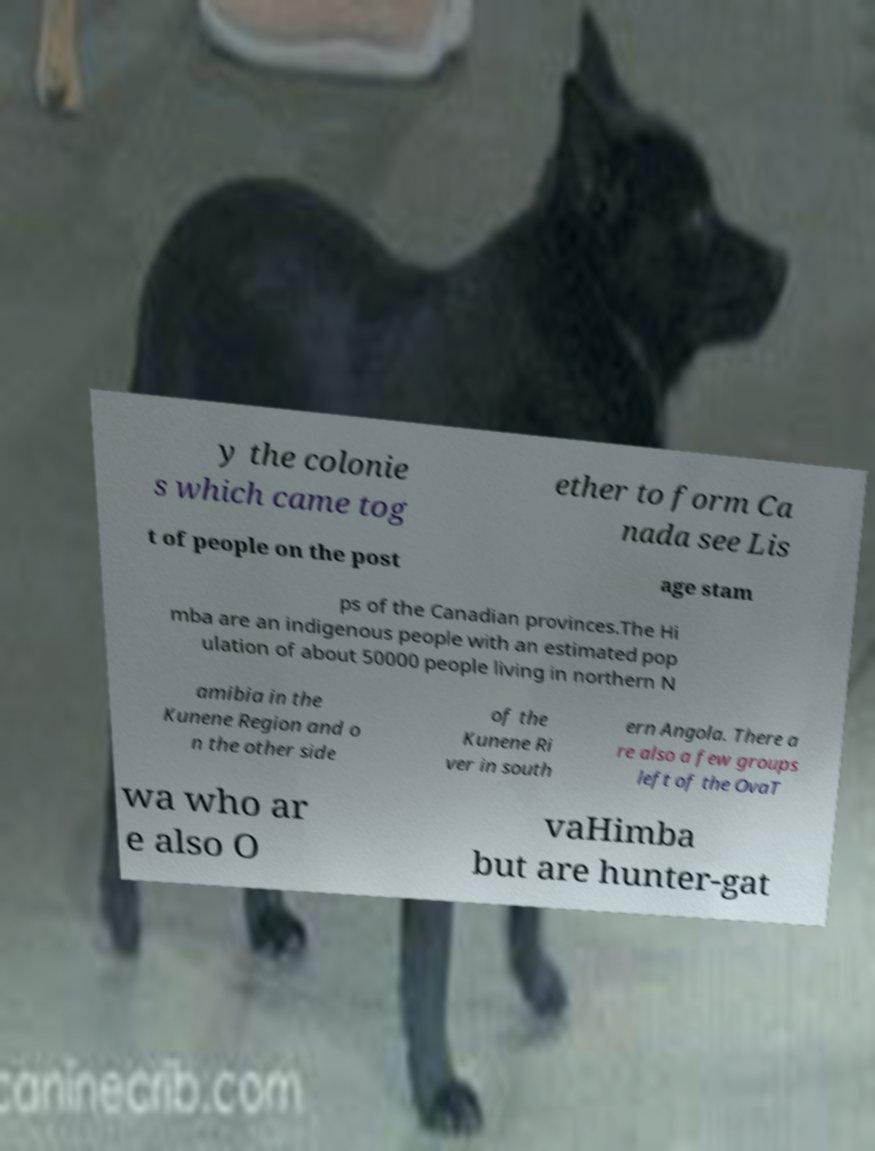Can you read and provide the text displayed in the image?This photo seems to have some interesting text. Can you extract and type it out for me? y the colonie s which came tog ether to form Ca nada see Lis t of people on the post age stam ps of the Canadian provinces.The Hi mba are an indigenous people with an estimated pop ulation of about 50000 people living in northern N amibia in the Kunene Region and o n the other side of the Kunene Ri ver in south ern Angola. There a re also a few groups left of the OvaT wa who ar e also O vaHimba but are hunter-gat 